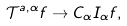Convert formula to latex. <formula><loc_0><loc_0><loc_500><loc_500>\mathcal { T } ^ { a , \alpha } f \to C _ { \alpha } I _ { \alpha } f ,</formula> 